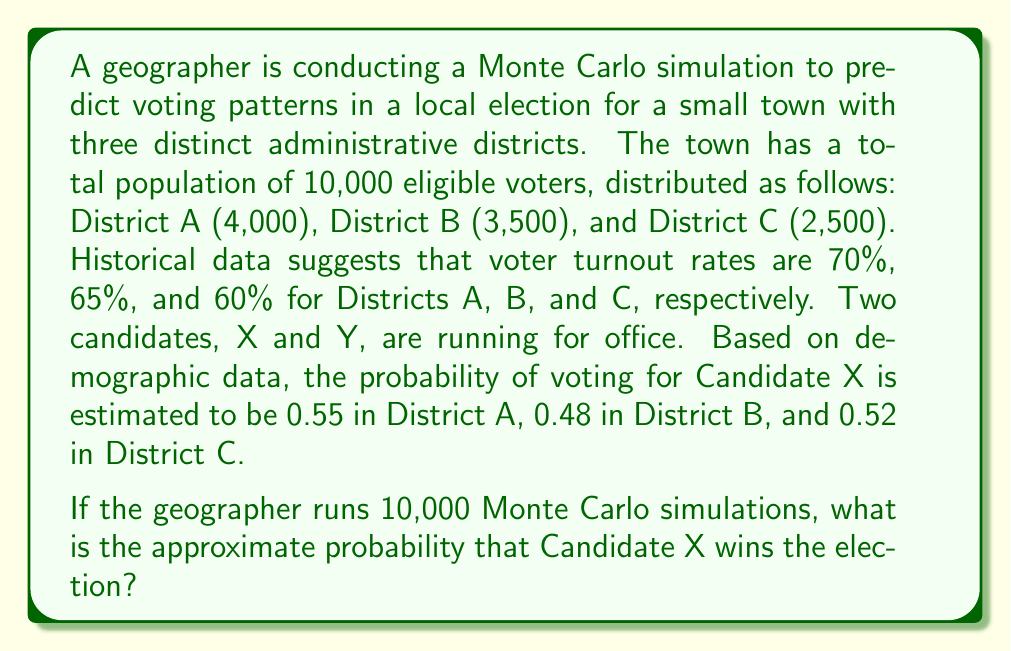Solve this math problem. To solve this problem, we'll follow these steps:

1. Calculate the expected number of voters in each district:
   District A: $4000 \times 0.70 = 2800$
   District B: $3500 \times 0.65 = 2275$
   District C: $2500 \times 0.60 = 1500$

2. Calculate the expected number of votes for Candidate X in each district:
   District A: $2800 \times 0.55 = 1540$
   District B: $2275 \times 0.48 = 1092$
   District C: $1500 \times 0.52 = 780$

3. Calculate the total expected votes for Candidate X:
   $1540 + 1092 + 780 = 3412$

4. Calculate the total expected number of voters:
   $2800 + 2275 + 1500 = 6575$

5. Calculate the expected proportion of votes for Candidate X:
   $\frac{3412}{6575} \approx 0.5189$

6. In a Monte Carlo simulation, we would generate random outcomes based on these probabilities. The Central Limit Theorem suggests that the distribution of outcomes will approximate a normal distribution.

7. Since the expected proportion of votes for Candidate X is greater than 0.5, we can expect Candidate X to win more than half of the simulations.

8. To estimate the probability of Candidate X winning, we can use the normal approximation:

   $Z = \frac{p - 0.5}{\sqrt{\frac{0.5(1-0.5)}{n}}}$

   Where $p = 0.5189$ and $n = 6575$

   $Z = \frac{0.5189 - 0.5}{\sqrt{\frac{0.5(1-0.5)}{6575}}} \approx 3.07$

9. Using a standard normal distribution table or calculator, we find that the probability corresponding to $Z = 3.07$ is approximately 0.9989.

Therefore, in 10,000 Monte Carlo simulations, we would expect Candidate X to win approximately 9,989 times.
Answer: 0.9989 